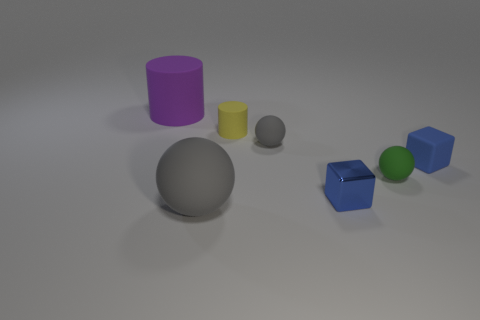Subtract all small green balls. How many balls are left? 2 Add 1 tiny blue cylinders. How many objects exist? 8 Subtract all yellow cylinders. How many cylinders are left? 1 Subtract all cylinders. How many objects are left? 5 Subtract 1 blocks. How many blocks are left? 1 Subtract 0 cyan spheres. How many objects are left? 7 Subtract all yellow balls. Subtract all purple cubes. How many balls are left? 3 Subtract all cyan cubes. How many green balls are left? 1 Subtract all large purple metal cylinders. Subtract all small gray rubber spheres. How many objects are left? 6 Add 2 large gray spheres. How many large gray spheres are left? 3 